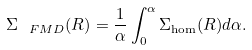Convert formula to latex. <formula><loc_0><loc_0><loc_500><loc_500>\Sigma _ { \ F M D } ( R ) = \frac { 1 } { \alpha } \int _ { 0 } ^ { \alpha } { \Sigma _ { \hom } ( R ) d \alpha } .</formula> 